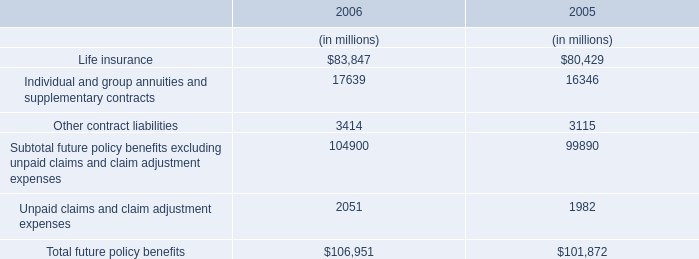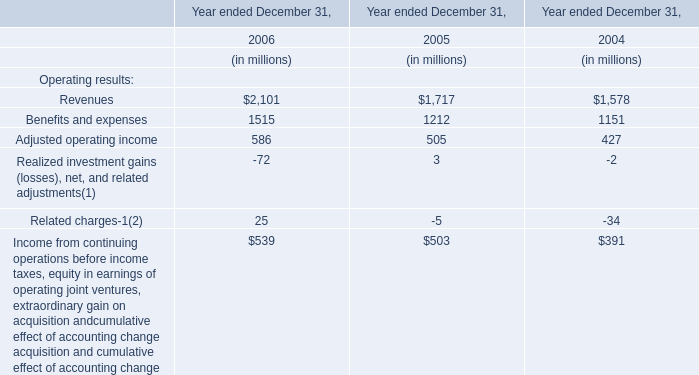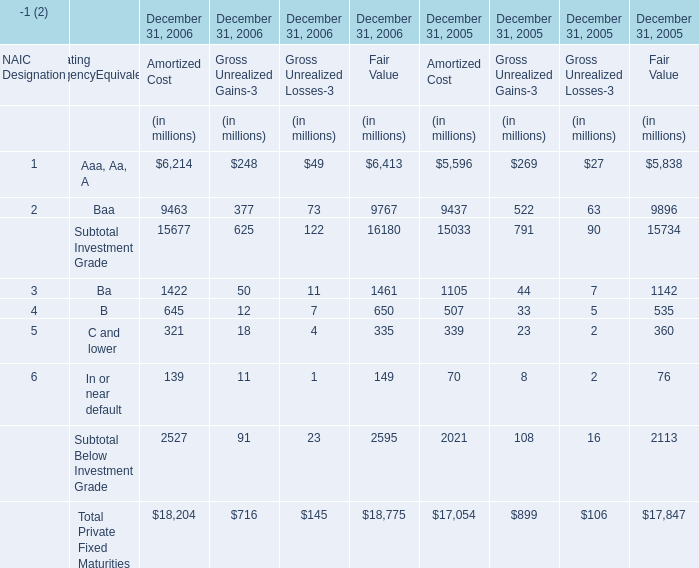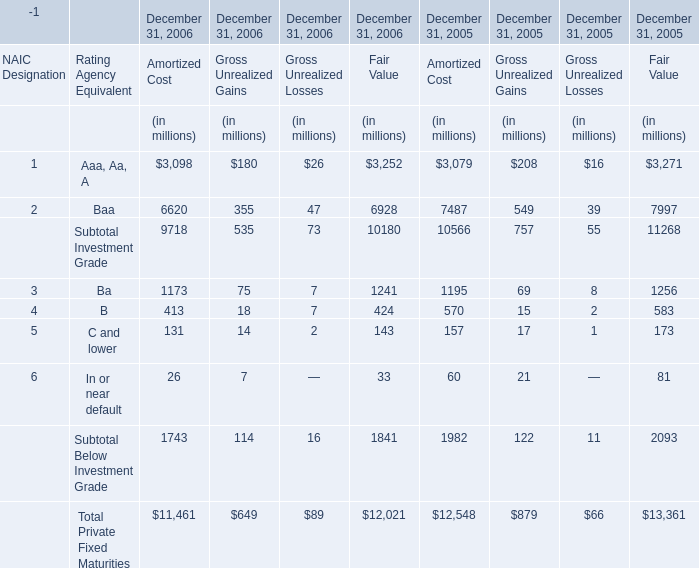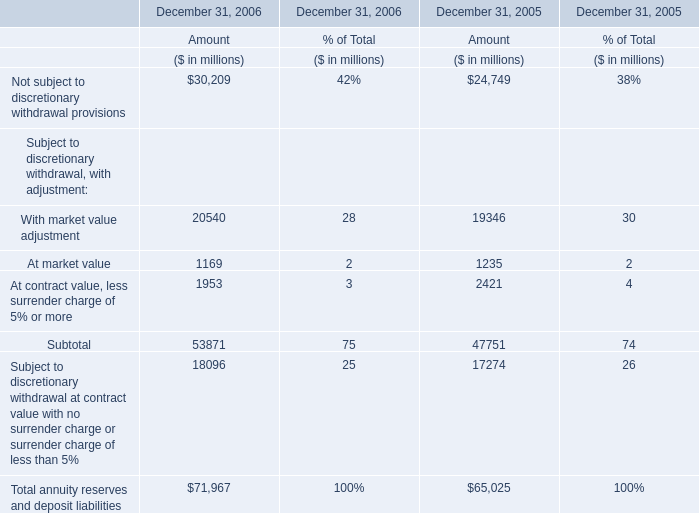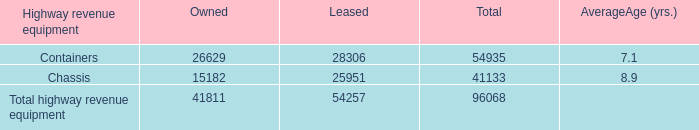In the year with the most Aaa, Aa, A for Amortized, what is the growth rate of B of Rating AgencyEquivalent for Amortized? 
Computations: ((645 - 507) / 645)
Answer: 0.21395. 